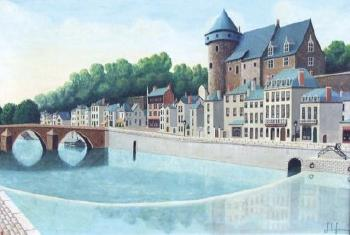What historical era do you think the architecture of the main building suggests? The main building with a turret appears to be inspired by medieval architecture, commonly seen in historical European castles and fortified structures, which suggests that the building or town has roots or influences stretching back to the Middle Ages. 